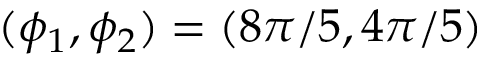<formula> <loc_0><loc_0><loc_500><loc_500>( \phi _ { 1 } , \phi _ { 2 } ) = ( 8 \pi / 5 , 4 \pi / 5 )</formula> 